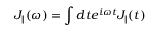Convert formula to latex. <formula><loc_0><loc_0><loc_500><loc_500>J _ { \| } ( \omega ) = \int d t e ^ { i \omega t } J _ { \| } ( t )</formula> 